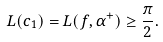Convert formula to latex. <formula><loc_0><loc_0><loc_500><loc_500>L ( c _ { 1 } ) = L ( f , \alpha ^ { + } ) \geq \frac { \pi } { 2 } .</formula> 